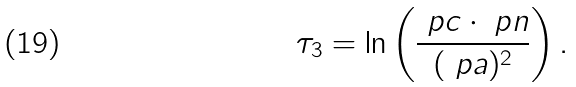Convert formula to latex. <formula><loc_0><loc_0><loc_500><loc_500>\tau _ { 3 } = \ln \left ( \frac { \ p c \cdot \ p n } { ( \ p a ) ^ { 2 } } \right ) .</formula> 